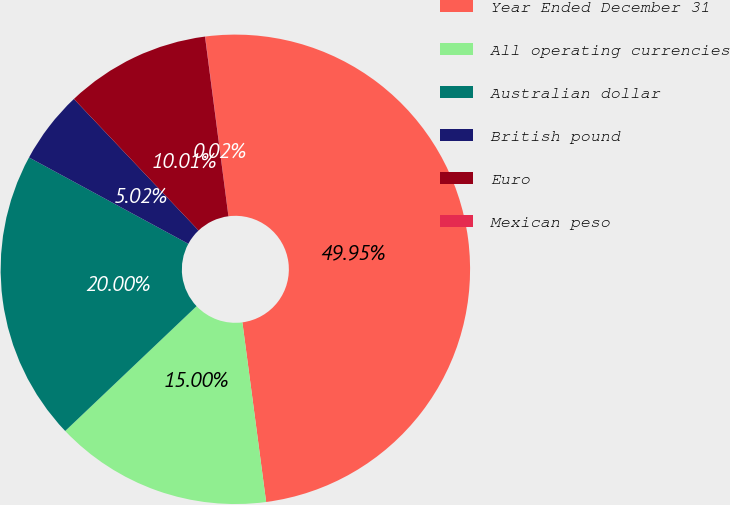<chart> <loc_0><loc_0><loc_500><loc_500><pie_chart><fcel>Year Ended December 31<fcel>All operating currencies<fcel>Australian dollar<fcel>British pound<fcel>Euro<fcel>Mexican peso<nl><fcel>49.95%<fcel>15.0%<fcel>20.0%<fcel>5.02%<fcel>10.01%<fcel>0.02%<nl></chart> 